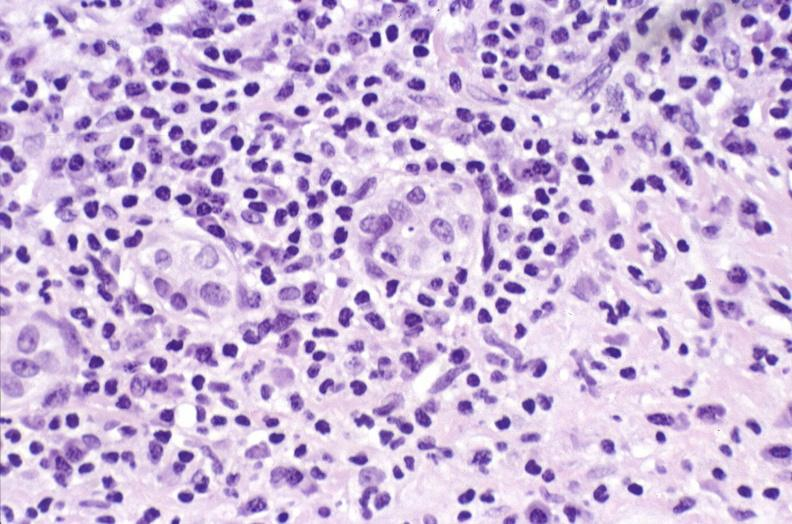what is present?
Answer the question using a single word or phrase. Liver 